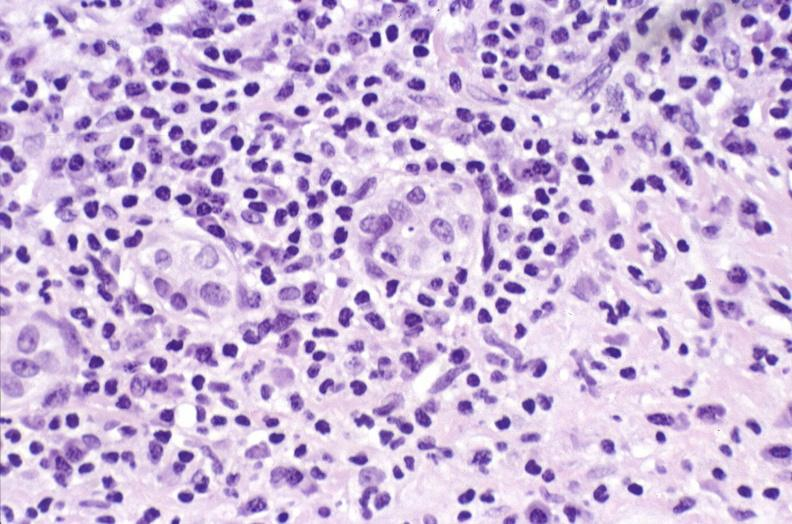what is present?
Answer the question using a single word or phrase. Liver 